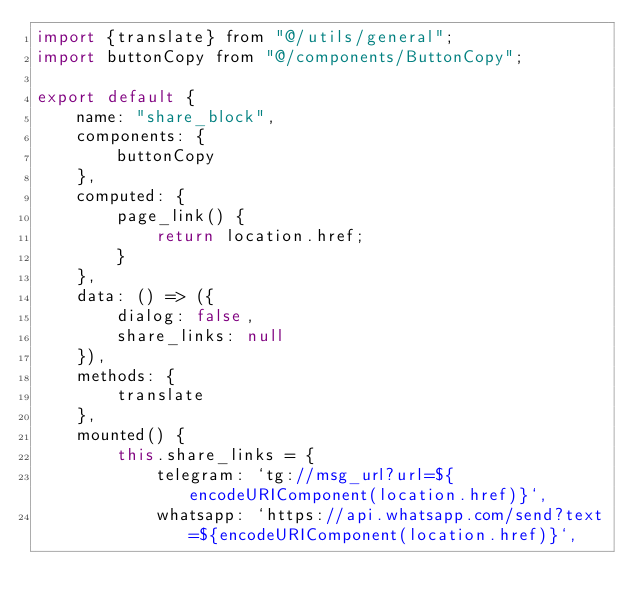<code> <loc_0><loc_0><loc_500><loc_500><_JavaScript_>import {translate} from "@/utils/general";
import buttonCopy from "@/components/ButtonCopy";

export default {
    name: "share_block",
    components: {
        buttonCopy
    },
    computed: {
        page_link() {
            return location.href;
        }
    },
    data: () => ({
        dialog: false,
        share_links: null
    }),
    methods: {
        translate
    },
    mounted() {
        this.share_links = {
            telegram: `tg://msg_url?url=${encodeURIComponent(location.href)}`,
            whatsapp: `https://api.whatsapp.com/send?text=${encodeURIComponent(location.href)}`,</code> 